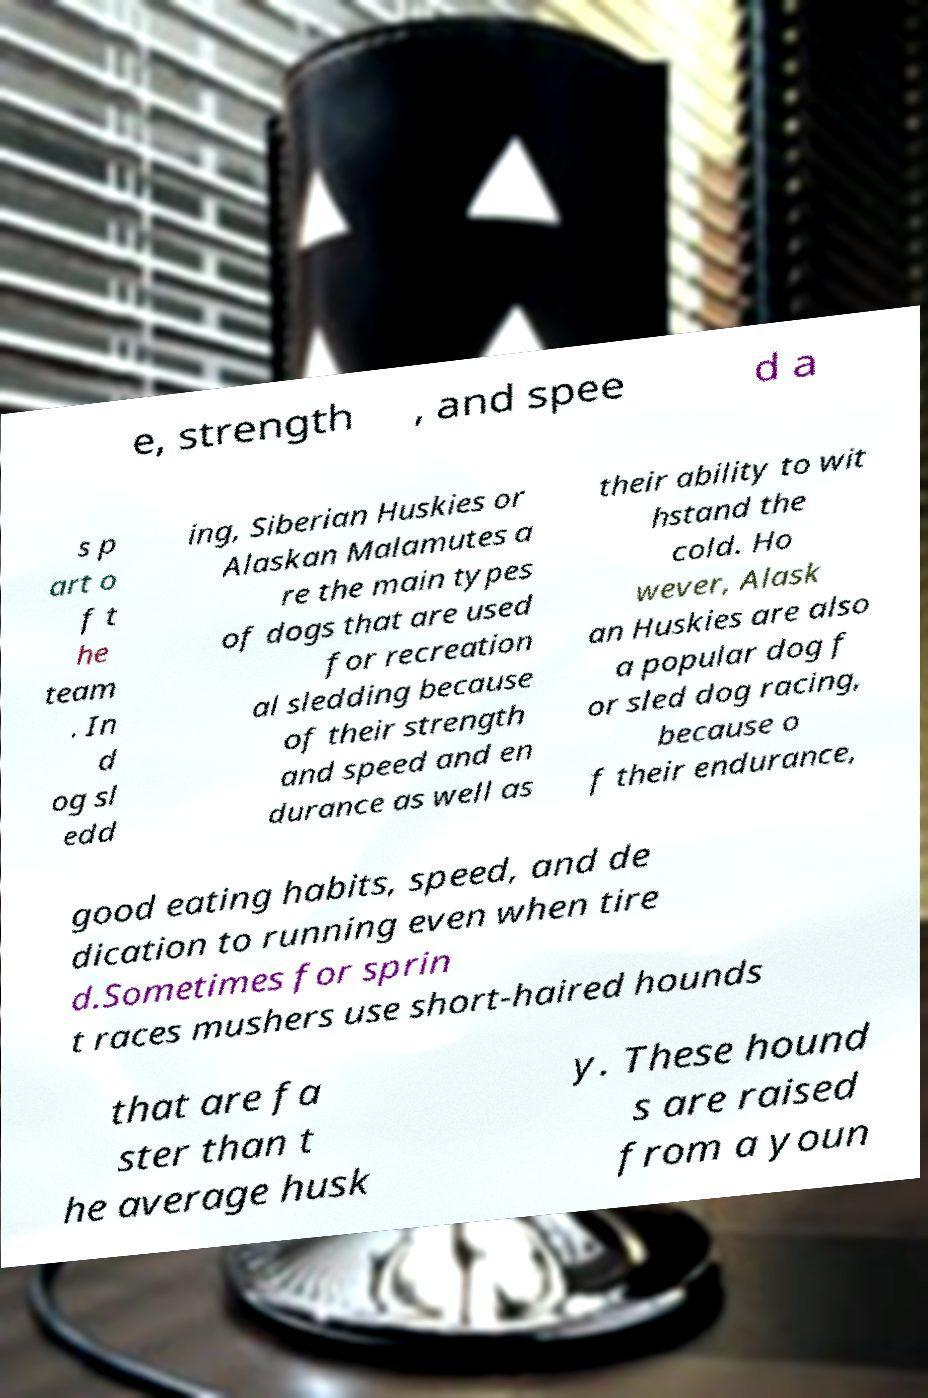Can you read and provide the text displayed in the image?This photo seems to have some interesting text. Can you extract and type it out for me? e, strength , and spee d a s p art o f t he team . In d og sl edd ing, Siberian Huskies or Alaskan Malamutes a re the main types of dogs that are used for recreation al sledding because of their strength and speed and en durance as well as their ability to wit hstand the cold. Ho wever, Alask an Huskies are also a popular dog f or sled dog racing, because o f their endurance, good eating habits, speed, and de dication to running even when tire d.Sometimes for sprin t races mushers use short-haired hounds that are fa ster than t he average husk y. These hound s are raised from a youn 